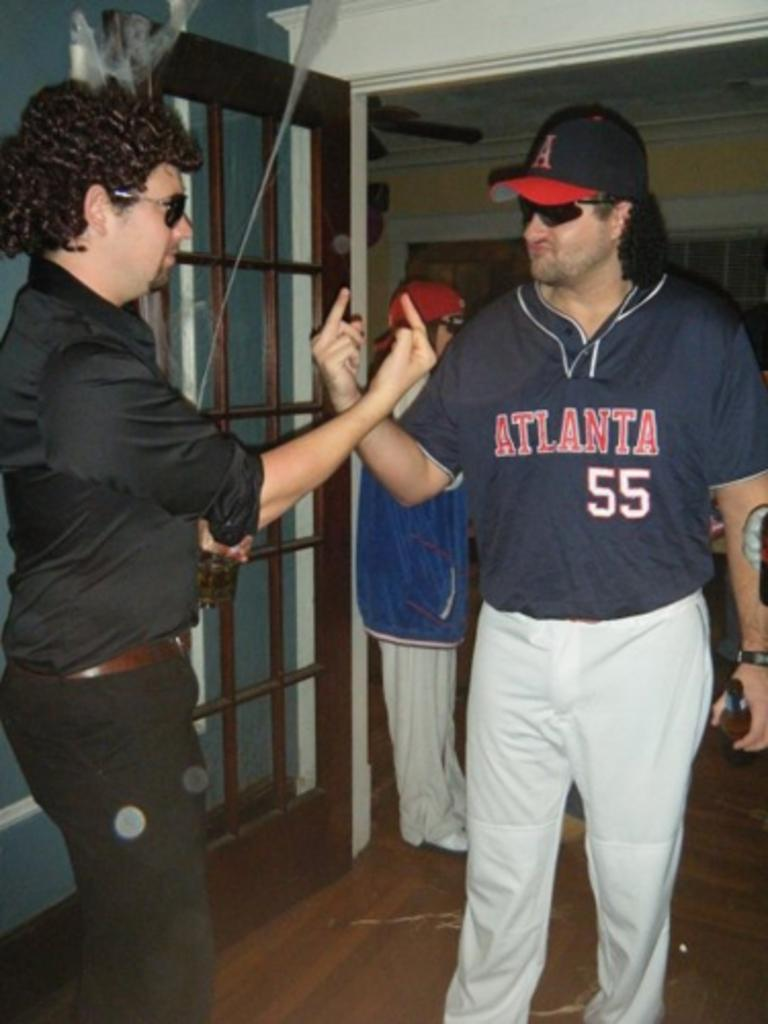Provide a one-sentence caption for the provided image. Two men, one of which is wearing a jersey for an Atlanta team with the number 55, flip off each other. 